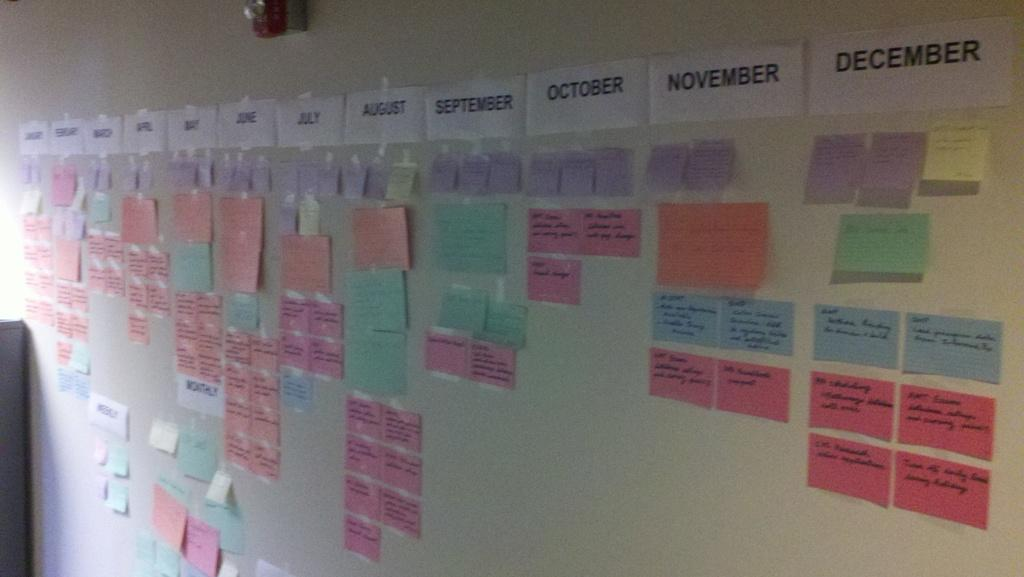<image>
Create a compact narrative representing the image presented. Taped to a wall is a row containing the months of the year. 